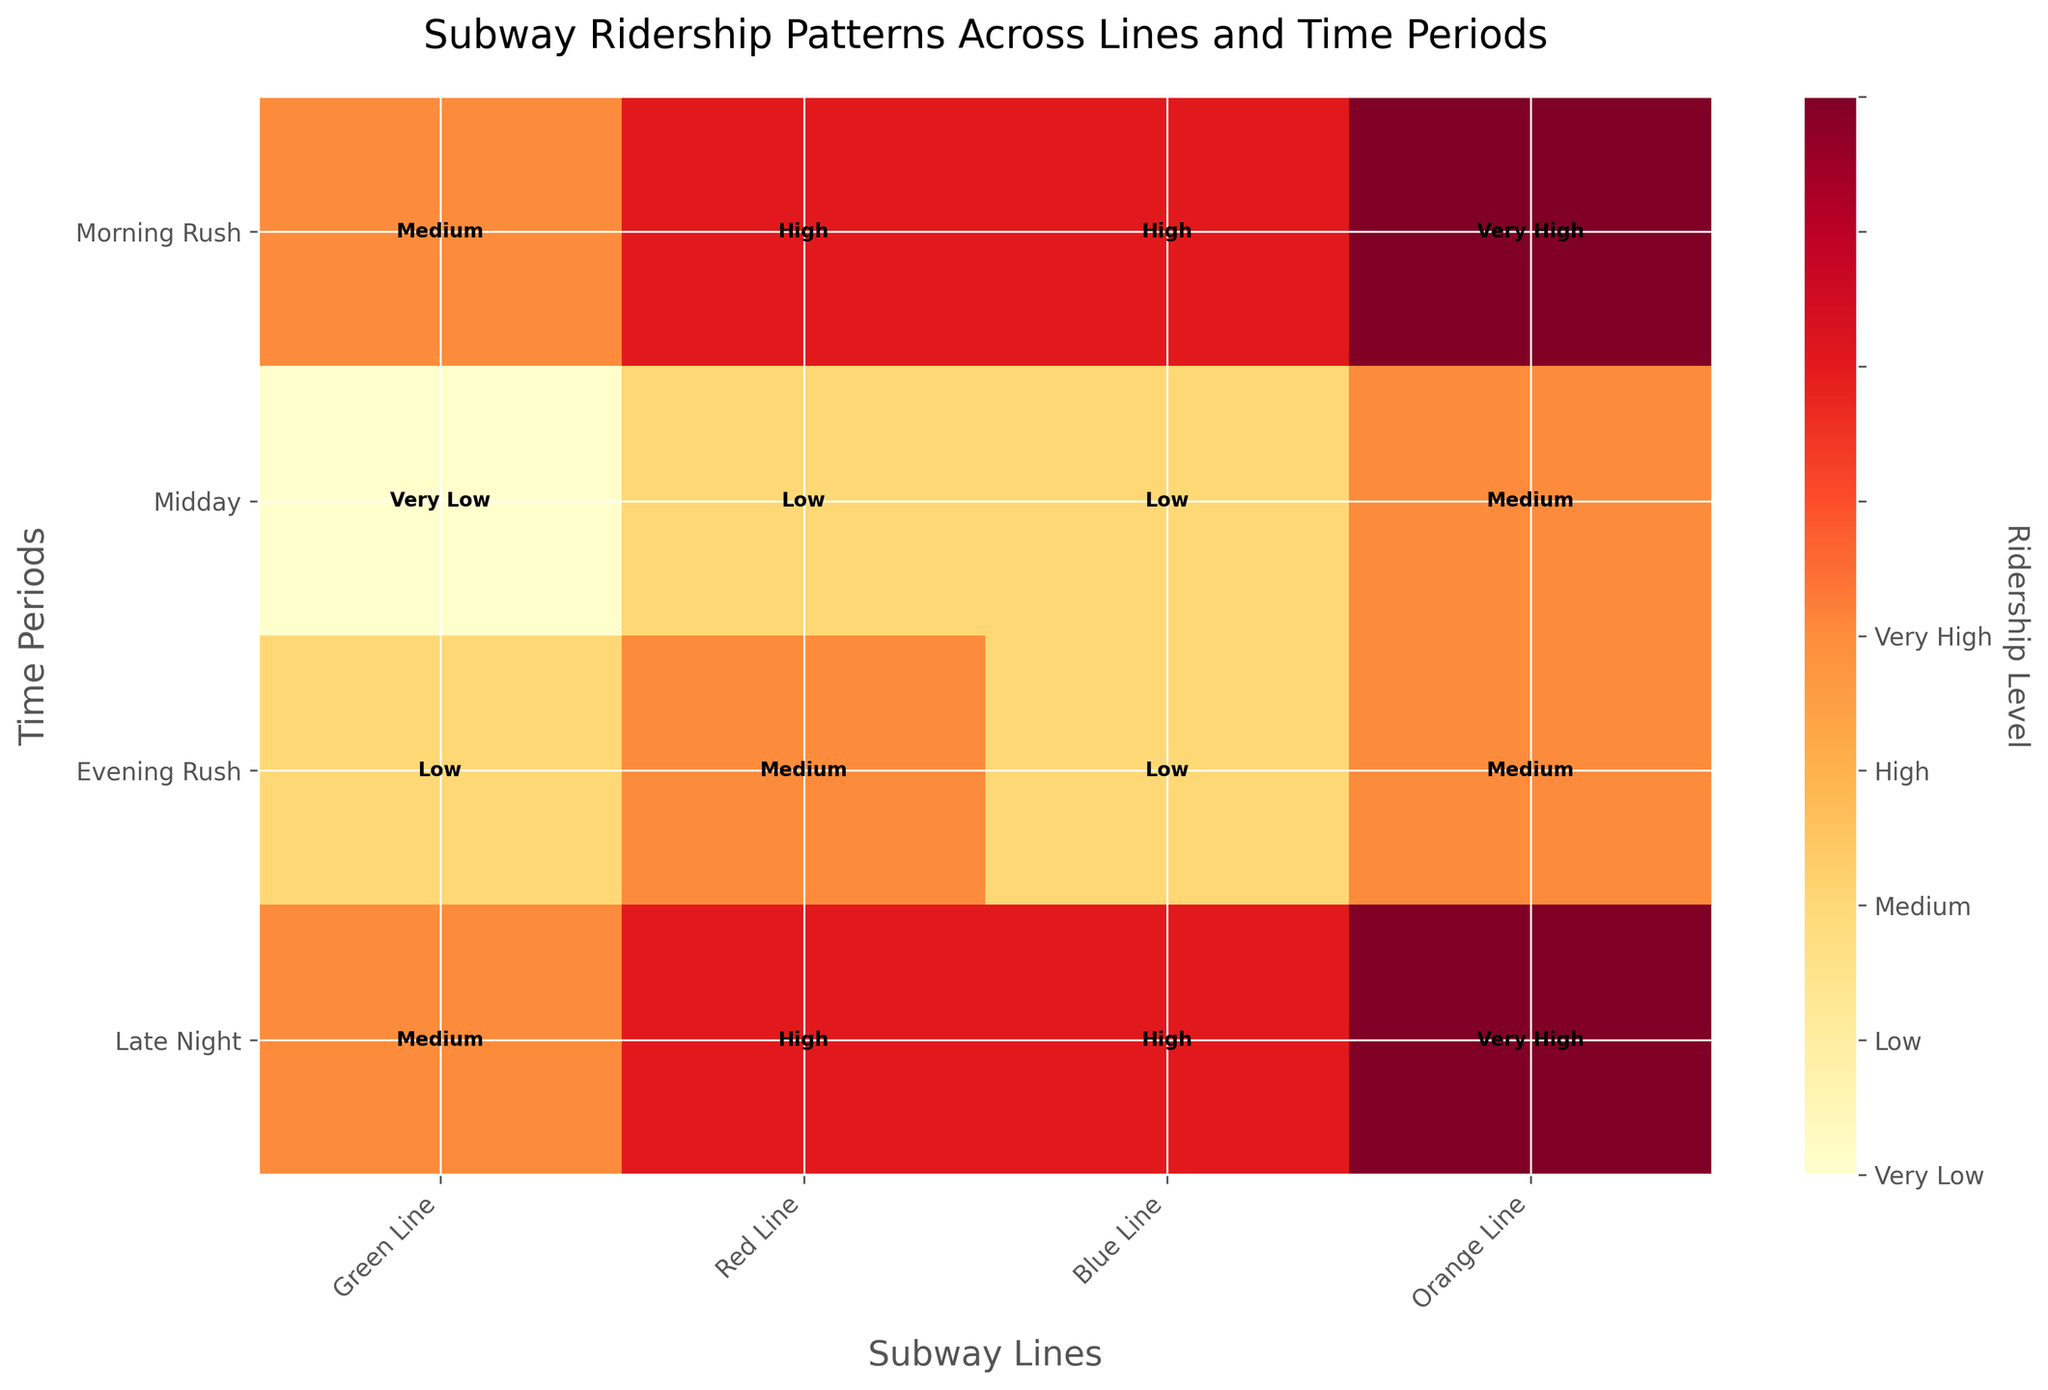Which subway line has the highest ridership level during the Morning Rush? To find this, look at the row labeled "Morning Rush" and identify the color corresponding to the highest ridership level. The Red Line is marked "Very High".
Answer: Red Line What is the ridership level for the Blue Line during Late Night? Locate the intersection of the "Blue Line" column and the "Late Night" row. The mosaic plot marks this cell with "Very Low".
Answer: Very Low Compare the ridership levels of the Green Line and the Orange Line during Midday. Which one is higher? Find the "Midday" row and compare the values for the Green Line and Orange Line. The Green Line has a "Medium" value, while the Orange Line has a "Low" value.
Answer: Green Line Which time period has the lowest ridership for the Red Line? Look down the Red Line column to find the lowest ridership value, which is "Medium" at both Midday and Late Night periods.
Answer: Midday, Late Night How does the ridership pattern of the Green Line during the Evening Rush compare to the Morning Rush? Check the values for the Green Line during "Evening Rush" and "Morning Rush". Both times show "High" ridership.
Answer: High, High What's the overall trend for Orange Line ridership levels across all time periods? Check the values for the Orange Line across all time periods: Morning Rush (High), Midday (Low), Evening Rush (High), Late Night (Low), showing alternating high and low trends.
Answer: Alternating High and Low What is the color representing the Medium ridership level in this plot? Refer to the colorbar or identify a cell marked "Medium" to determine its color.
Answer: A medium shade of orange How dominant is the Red Line during the Evening Rush compared to the other lines? Inspect the "Evening Rush" row and observe the value for each line. The Red Line shows "Very High" ridership, higher than "High" for Green and Orange Lines, and "Medium" for Blue Line.
Answer: Very High, High, Medium During which time period does the Blue Line have the same ridership level as the Green Line? Locate the rows for Blue Line and Green Line with matching values. Both show "Medium" ridership during the Morning Rush and Evening Rush.
Answer: Morning Rush, Evening Rush 